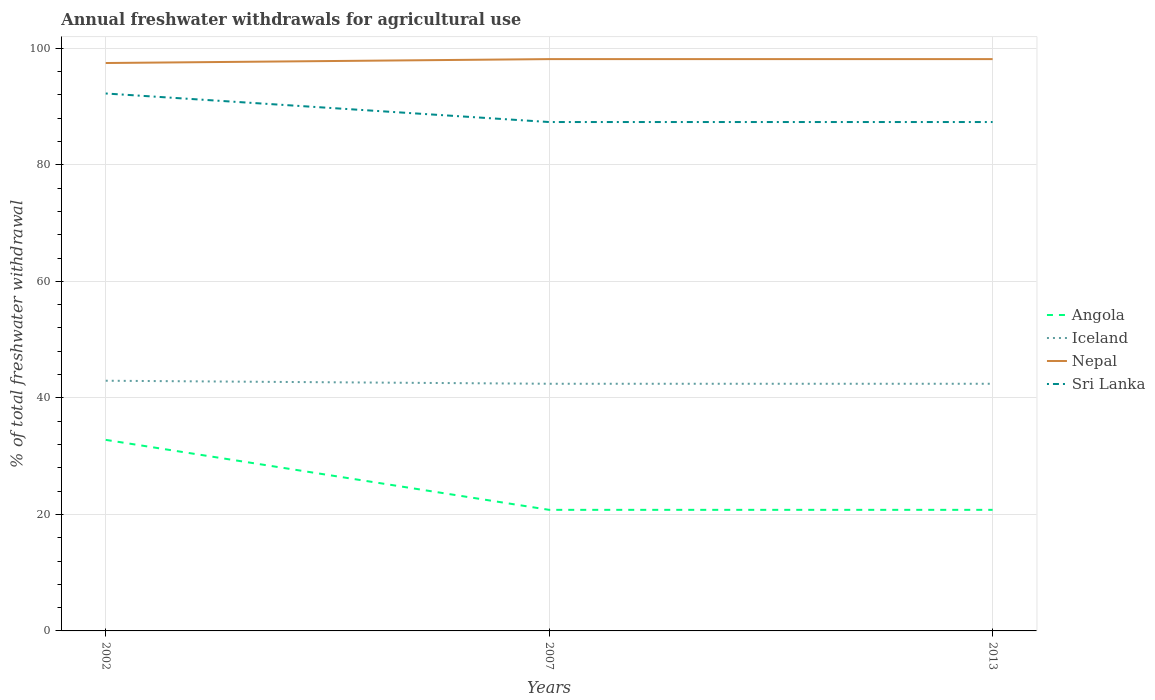Is the number of lines equal to the number of legend labels?
Give a very brief answer. Yes. Across all years, what is the maximum total annual withdrawals from freshwater in Sri Lanka?
Your answer should be compact. 87.34. What is the total total annual withdrawals from freshwater in Angola in the graph?
Keep it short and to the point. 12.01. What is the difference between the highest and the second highest total annual withdrawals from freshwater in Sri Lanka?
Give a very brief answer. 4.9. Is the total annual withdrawals from freshwater in Nepal strictly greater than the total annual withdrawals from freshwater in Sri Lanka over the years?
Your response must be concise. No. How many lines are there?
Offer a very short reply. 4. What is the difference between two consecutive major ticks on the Y-axis?
Offer a terse response. 20. Does the graph contain grids?
Offer a terse response. Yes. How are the legend labels stacked?
Your answer should be very brief. Vertical. What is the title of the graph?
Offer a terse response. Annual freshwater withdrawals for agricultural use. What is the label or title of the Y-axis?
Your response must be concise. % of total freshwater withdrawal. What is the % of total freshwater withdrawal of Angola in 2002?
Give a very brief answer. 32.79. What is the % of total freshwater withdrawal in Iceland in 2002?
Offer a very short reply. 42.94. What is the % of total freshwater withdrawal in Nepal in 2002?
Provide a succinct answer. 97.47. What is the % of total freshwater withdrawal of Sri Lanka in 2002?
Make the answer very short. 92.24. What is the % of total freshwater withdrawal in Angola in 2007?
Ensure brevity in your answer.  20.78. What is the % of total freshwater withdrawal in Iceland in 2007?
Provide a short and direct response. 42.42. What is the % of total freshwater withdrawal of Nepal in 2007?
Keep it short and to the point. 98.14. What is the % of total freshwater withdrawal of Sri Lanka in 2007?
Provide a short and direct response. 87.34. What is the % of total freshwater withdrawal in Angola in 2013?
Your answer should be very brief. 20.78. What is the % of total freshwater withdrawal in Iceland in 2013?
Your response must be concise. 42.42. What is the % of total freshwater withdrawal of Nepal in 2013?
Offer a very short reply. 98.14. What is the % of total freshwater withdrawal in Sri Lanka in 2013?
Your answer should be compact. 87.34. Across all years, what is the maximum % of total freshwater withdrawal of Angola?
Make the answer very short. 32.79. Across all years, what is the maximum % of total freshwater withdrawal in Iceland?
Give a very brief answer. 42.94. Across all years, what is the maximum % of total freshwater withdrawal of Nepal?
Keep it short and to the point. 98.14. Across all years, what is the maximum % of total freshwater withdrawal in Sri Lanka?
Provide a short and direct response. 92.24. Across all years, what is the minimum % of total freshwater withdrawal in Angola?
Keep it short and to the point. 20.78. Across all years, what is the minimum % of total freshwater withdrawal in Iceland?
Your response must be concise. 42.42. Across all years, what is the minimum % of total freshwater withdrawal of Nepal?
Offer a very short reply. 97.47. Across all years, what is the minimum % of total freshwater withdrawal in Sri Lanka?
Your response must be concise. 87.34. What is the total % of total freshwater withdrawal of Angola in the graph?
Your answer should be very brief. 74.35. What is the total % of total freshwater withdrawal of Iceland in the graph?
Your response must be concise. 127.78. What is the total % of total freshwater withdrawal of Nepal in the graph?
Your answer should be compact. 293.75. What is the total % of total freshwater withdrawal of Sri Lanka in the graph?
Offer a very short reply. 266.92. What is the difference between the % of total freshwater withdrawal of Angola in 2002 and that in 2007?
Offer a terse response. 12.01. What is the difference between the % of total freshwater withdrawal of Iceland in 2002 and that in 2007?
Ensure brevity in your answer.  0.52. What is the difference between the % of total freshwater withdrawal of Nepal in 2002 and that in 2007?
Your response must be concise. -0.67. What is the difference between the % of total freshwater withdrawal in Sri Lanka in 2002 and that in 2007?
Make the answer very short. 4.9. What is the difference between the % of total freshwater withdrawal in Angola in 2002 and that in 2013?
Ensure brevity in your answer.  12.01. What is the difference between the % of total freshwater withdrawal of Iceland in 2002 and that in 2013?
Provide a succinct answer. 0.52. What is the difference between the % of total freshwater withdrawal in Nepal in 2002 and that in 2013?
Provide a succinct answer. -0.67. What is the difference between the % of total freshwater withdrawal in Sri Lanka in 2002 and that in 2013?
Your answer should be compact. 4.9. What is the difference between the % of total freshwater withdrawal of Nepal in 2007 and that in 2013?
Keep it short and to the point. 0. What is the difference between the % of total freshwater withdrawal of Angola in 2002 and the % of total freshwater withdrawal of Iceland in 2007?
Provide a succinct answer. -9.63. What is the difference between the % of total freshwater withdrawal in Angola in 2002 and the % of total freshwater withdrawal in Nepal in 2007?
Give a very brief answer. -65.35. What is the difference between the % of total freshwater withdrawal of Angola in 2002 and the % of total freshwater withdrawal of Sri Lanka in 2007?
Ensure brevity in your answer.  -54.55. What is the difference between the % of total freshwater withdrawal of Iceland in 2002 and the % of total freshwater withdrawal of Nepal in 2007?
Give a very brief answer. -55.2. What is the difference between the % of total freshwater withdrawal in Iceland in 2002 and the % of total freshwater withdrawal in Sri Lanka in 2007?
Your answer should be very brief. -44.4. What is the difference between the % of total freshwater withdrawal in Nepal in 2002 and the % of total freshwater withdrawal in Sri Lanka in 2007?
Provide a short and direct response. 10.13. What is the difference between the % of total freshwater withdrawal in Angola in 2002 and the % of total freshwater withdrawal in Iceland in 2013?
Your answer should be very brief. -9.63. What is the difference between the % of total freshwater withdrawal of Angola in 2002 and the % of total freshwater withdrawal of Nepal in 2013?
Offer a terse response. -65.35. What is the difference between the % of total freshwater withdrawal in Angola in 2002 and the % of total freshwater withdrawal in Sri Lanka in 2013?
Offer a terse response. -54.55. What is the difference between the % of total freshwater withdrawal in Iceland in 2002 and the % of total freshwater withdrawal in Nepal in 2013?
Provide a succinct answer. -55.2. What is the difference between the % of total freshwater withdrawal in Iceland in 2002 and the % of total freshwater withdrawal in Sri Lanka in 2013?
Offer a terse response. -44.4. What is the difference between the % of total freshwater withdrawal of Nepal in 2002 and the % of total freshwater withdrawal of Sri Lanka in 2013?
Keep it short and to the point. 10.13. What is the difference between the % of total freshwater withdrawal in Angola in 2007 and the % of total freshwater withdrawal in Iceland in 2013?
Your answer should be compact. -21.64. What is the difference between the % of total freshwater withdrawal in Angola in 2007 and the % of total freshwater withdrawal in Nepal in 2013?
Your answer should be very brief. -77.36. What is the difference between the % of total freshwater withdrawal in Angola in 2007 and the % of total freshwater withdrawal in Sri Lanka in 2013?
Make the answer very short. -66.56. What is the difference between the % of total freshwater withdrawal of Iceland in 2007 and the % of total freshwater withdrawal of Nepal in 2013?
Keep it short and to the point. -55.72. What is the difference between the % of total freshwater withdrawal in Iceland in 2007 and the % of total freshwater withdrawal in Sri Lanka in 2013?
Make the answer very short. -44.92. What is the average % of total freshwater withdrawal in Angola per year?
Your answer should be compact. 24.78. What is the average % of total freshwater withdrawal in Iceland per year?
Provide a short and direct response. 42.59. What is the average % of total freshwater withdrawal in Nepal per year?
Ensure brevity in your answer.  97.92. What is the average % of total freshwater withdrawal of Sri Lanka per year?
Provide a short and direct response. 88.97. In the year 2002, what is the difference between the % of total freshwater withdrawal of Angola and % of total freshwater withdrawal of Iceland?
Keep it short and to the point. -10.15. In the year 2002, what is the difference between the % of total freshwater withdrawal of Angola and % of total freshwater withdrawal of Nepal?
Make the answer very short. -64.68. In the year 2002, what is the difference between the % of total freshwater withdrawal in Angola and % of total freshwater withdrawal in Sri Lanka?
Your answer should be very brief. -59.45. In the year 2002, what is the difference between the % of total freshwater withdrawal in Iceland and % of total freshwater withdrawal in Nepal?
Make the answer very short. -54.53. In the year 2002, what is the difference between the % of total freshwater withdrawal of Iceland and % of total freshwater withdrawal of Sri Lanka?
Provide a succinct answer. -49.3. In the year 2002, what is the difference between the % of total freshwater withdrawal in Nepal and % of total freshwater withdrawal in Sri Lanka?
Provide a succinct answer. 5.23. In the year 2007, what is the difference between the % of total freshwater withdrawal of Angola and % of total freshwater withdrawal of Iceland?
Provide a short and direct response. -21.64. In the year 2007, what is the difference between the % of total freshwater withdrawal in Angola and % of total freshwater withdrawal in Nepal?
Your answer should be very brief. -77.36. In the year 2007, what is the difference between the % of total freshwater withdrawal in Angola and % of total freshwater withdrawal in Sri Lanka?
Provide a short and direct response. -66.56. In the year 2007, what is the difference between the % of total freshwater withdrawal in Iceland and % of total freshwater withdrawal in Nepal?
Your response must be concise. -55.72. In the year 2007, what is the difference between the % of total freshwater withdrawal of Iceland and % of total freshwater withdrawal of Sri Lanka?
Keep it short and to the point. -44.92. In the year 2013, what is the difference between the % of total freshwater withdrawal in Angola and % of total freshwater withdrawal in Iceland?
Provide a succinct answer. -21.64. In the year 2013, what is the difference between the % of total freshwater withdrawal of Angola and % of total freshwater withdrawal of Nepal?
Give a very brief answer. -77.36. In the year 2013, what is the difference between the % of total freshwater withdrawal of Angola and % of total freshwater withdrawal of Sri Lanka?
Make the answer very short. -66.56. In the year 2013, what is the difference between the % of total freshwater withdrawal of Iceland and % of total freshwater withdrawal of Nepal?
Make the answer very short. -55.72. In the year 2013, what is the difference between the % of total freshwater withdrawal in Iceland and % of total freshwater withdrawal in Sri Lanka?
Offer a terse response. -44.92. What is the ratio of the % of total freshwater withdrawal of Angola in 2002 to that in 2007?
Ensure brevity in your answer.  1.58. What is the ratio of the % of total freshwater withdrawal in Iceland in 2002 to that in 2007?
Give a very brief answer. 1.01. What is the ratio of the % of total freshwater withdrawal of Nepal in 2002 to that in 2007?
Keep it short and to the point. 0.99. What is the ratio of the % of total freshwater withdrawal in Sri Lanka in 2002 to that in 2007?
Your response must be concise. 1.06. What is the ratio of the % of total freshwater withdrawal of Angola in 2002 to that in 2013?
Your answer should be compact. 1.58. What is the ratio of the % of total freshwater withdrawal in Iceland in 2002 to that in 2013?
Keep it short and to the point. 1.01. What is the ratio of the % of total freshwater withdrawal of Sri Lanka in 2002 to that in 2013?
Offer a very short reply. 1.06. What is the ratio of the % of total freshwater withdrawal in Angola in 2007 to that in 2013?
Your answer should be compact. 1. What is the ratio of the % of total freshwater withdrawal of Iceland in 2007 to that in 2013?
Your response must be concise. 1. What is the difference between the highest and the second highest % of total freshwater withdrawal in Angola?
Give a very brief answer. 12.01. What is the difference between the highest and the second highest % of total freshwater withdrawal in Iceland?
Your answer should be very brief. 0.52. What is the difference between the highest and the second highest % of total freshwater withdrawal in Nepal?
Provide a succinct answer. 0. What is the difference between the highest and the second highest % of total freshwater withdrawal of Sri Lanka?
Offer a terse response. 4.9. What is the difference between the highest and the lowest % of total freshwater withdrawal in Angola?
Your response must be concise. 12.01. What is the difference between the highest and the lowest % of total freshwater withdrawal of Iceland?
Keep it short and to the point. 0.52. What is the difference between the highest and the lowest % of total freshwater withdrawal of Nepal?
Offer a very short reply. 0.67. 